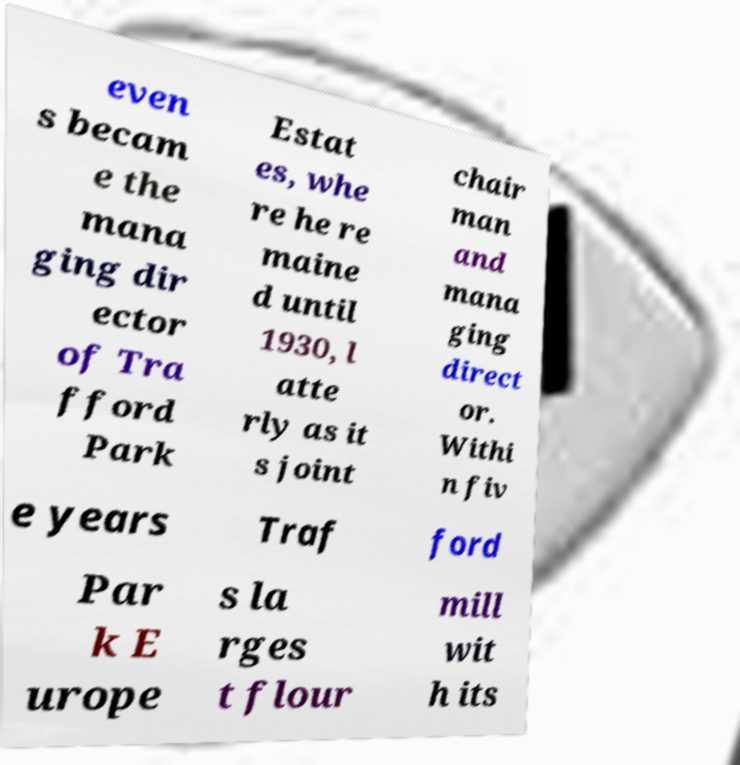Please read and relay the text visible in this image. What does it say? even s becam e the mana ging dir ector of Tra fford Park Estat es, whe re he re maine d until 1930, l atte rly as it s joint chair man and mana ging direct or. Withi n fiv e years Traf ford Par k E urope s la rges t flour mill wit h its 